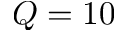<formula> <loc_0><loc_0><loc_500><loc_500>Q = 1 0</formula> 